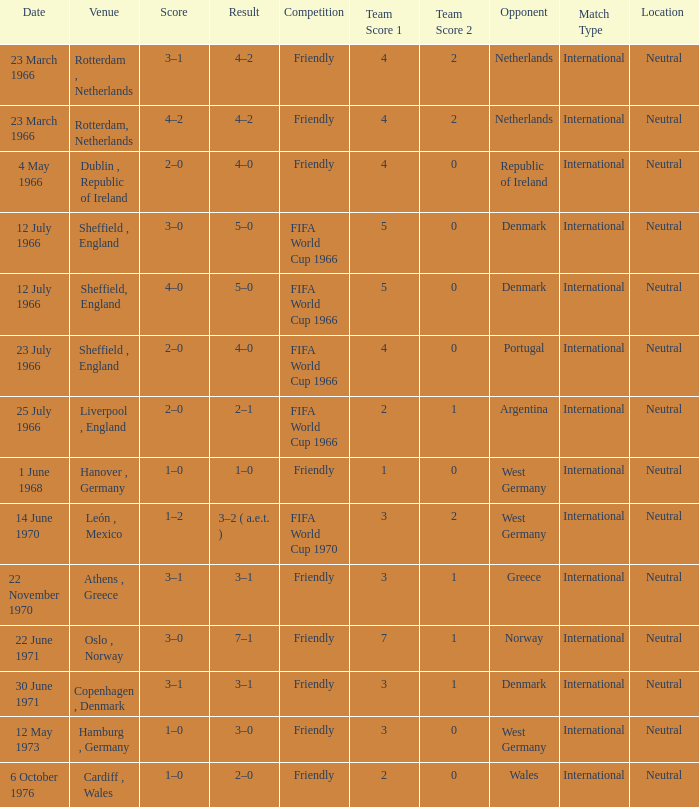Which result's venue was in Rotterdam, Netherlands? 4–2, 4–2. 